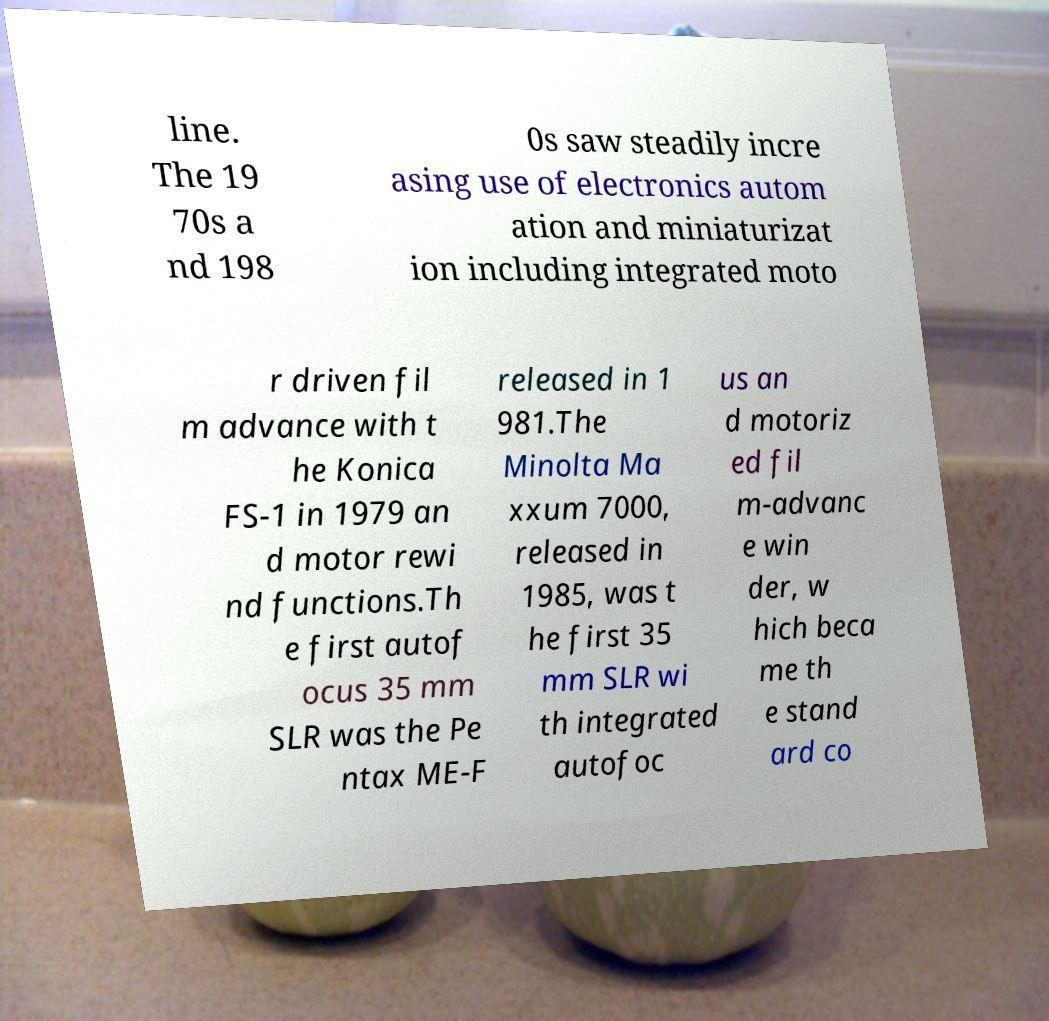I need the written content from this picture converted into text. Can you do that? line. The 19 70s a nd 198 0s saw steadily incre asing use of electronics autom ation and miniaturizat ion including integrated moto r driven fil m advance with t he Konica FS-1 in 1979 an d motor rewi nd functions.Th e first autof ocus 35 mm SLR was the Pe ntax ME-F released in 1 981.The Minolta Ma xxum 7000, released in 1985, was t he first 35 mm SLR wi th integrated autofoc us an d motoriz ed fil m-advanc e win der, w hich beca me th e stand ard co 